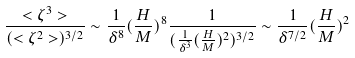Convert formula to latex. <formula><loc_0><loc_0><loc_500><loc_500>\frac { < \zeta ^ { 3 } > } { ( < \zeta ^ { 2 } > ) ^ { 3 / 2 } } \sim \frac { 1 } { \delta ^ { 8 } } ( \frac { H } { M } ) ^ { 8 } \frac { 1 } { ( \frac { 1 } { \delta ^ { 3 } } ( \frac { H } { M } ) ^ { 2 } ) ^ { 3 / 2 } } \sim \frac { 1 } { \delta ^ { 7 / 2 } } ( \frac { H } { M } ) ^ { 2 }</formula> 